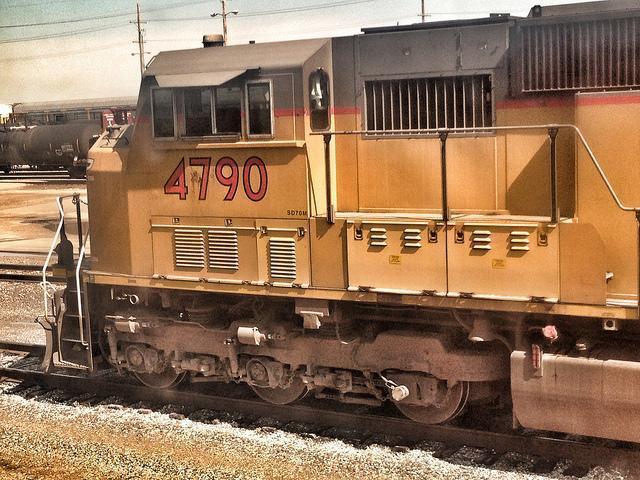How many trains can you see?
Give a very brief answer. 2. How many people are wearing a printed tee shirt?
Give a very brief answer. 0. 